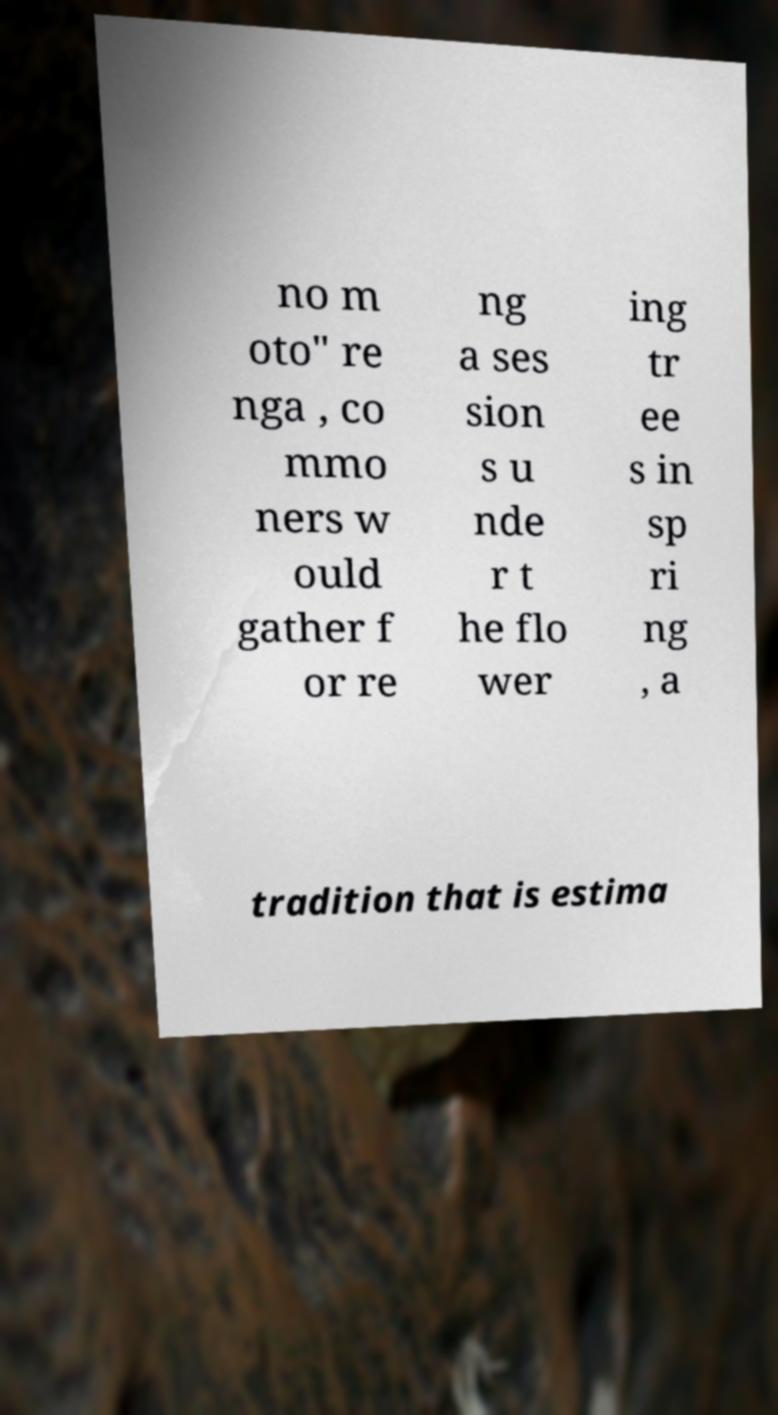Could you extract and type out the text from this image? no m oto" re nga , co mmo ners w ould gather f or re ng a ses sion s u nde r t he flo wer ing tr ee s in sp ri ng , a tradition that is estima 